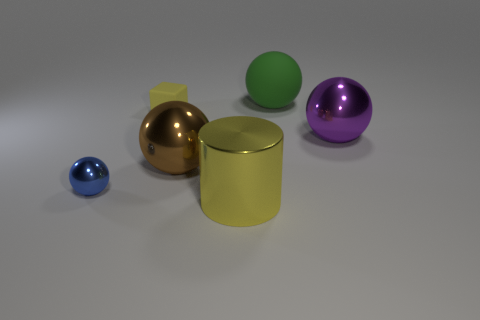Is the color of the tiny matte block the same as the cylinder?
Make the answer very short. Yes. There is a metallic thing in front of the blue thing; how many blue metallic balls are to the left of it?
Your answer should be very brief. 1. Are there fewer large purple spheres that are to the left of the big purple shiny object than big green spheres?
Give a very brief answer. Yes. There is a big metal sphere to the right of the large metallic object that is on the left side of the metal cylinder; are there any big purple shiny balls behind it?
Offer a very short reply. No. Does the yellow cube have the same material as the tiny object that is on the left side of the tiny matte block?
Provide a succinct answer. No. What is the color of the rubber thing behind the small thing that is to the right of the tiny blue shiny sphere?
Your answer should be compact. Green. Is there a rubber cube that has the same color as the tiny metal sphere?
Your answer should be compact. No. There is a metallic sphere to the left of the small thing behind the metallic ball in front of the brown thing; what size is it?
Your response must be concise. Small. Does the small yellow object have the same shape as the thing that is on the left side of the small yellow rubber cube?
Make the answer very short. No. How many other things are there of the same size as the blue object?
Give a very brief answer. 1. 